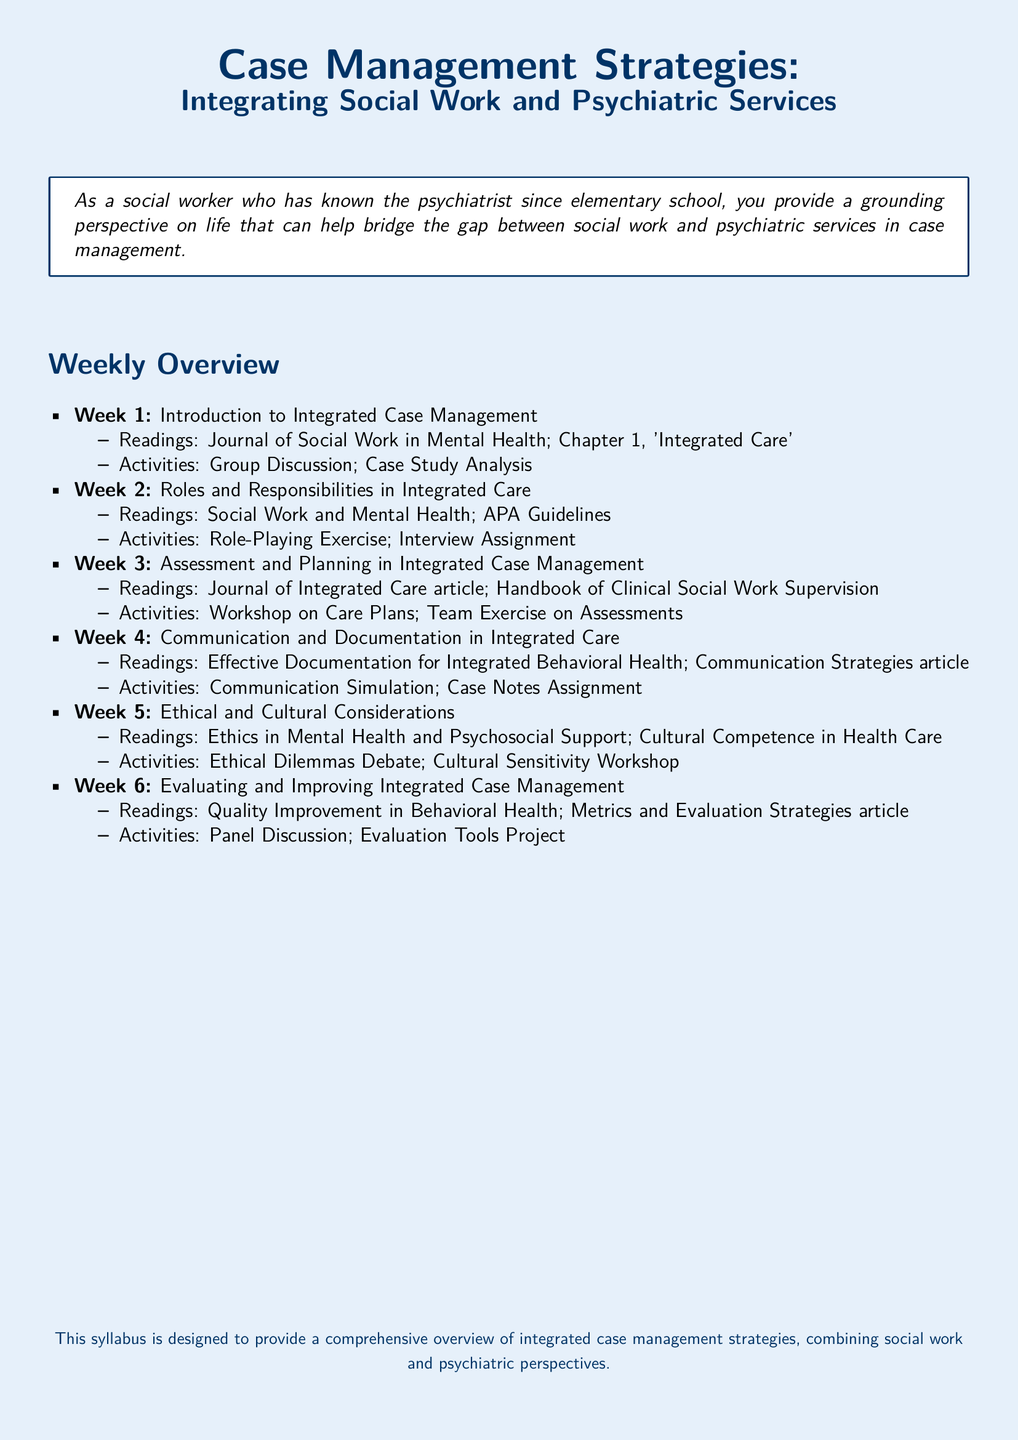What is the title of the syllabus? The title is presented at the beginning of the document.
Answer: Case Management Strategies: Integrating Social Work and Psychiatric Services How many weeks are covered in the syllabus? The syllabus outlines activities for six weeks.
Answer: 6 What is the focus of Week 5? Week 5 highlights ethical considerations and cultural competence.
Answer: Ethical and Cultural Considerations Which publication is recommended for readings in Week 3? The syllabus lists specific readings associated with each week.
Answer: Journal of Integrated Care article What type of activity is planned for Week 2? Each week includes varied activities, including experiential learning.
Answer: Role-Playing Exercise What is the primary goal of this syllabus? The purpose is outlined in the conclusion of the document.
Answer: To provide a comprehensive overview of integrated case management strategies 